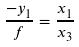Convert formula to latex. <formula><loc_0><loc_0><loc_500><loc_500>\frac { - y _ { 1 } } { f } = \frac { x _ { 1 } } { x _ { 3 } }</formula> 